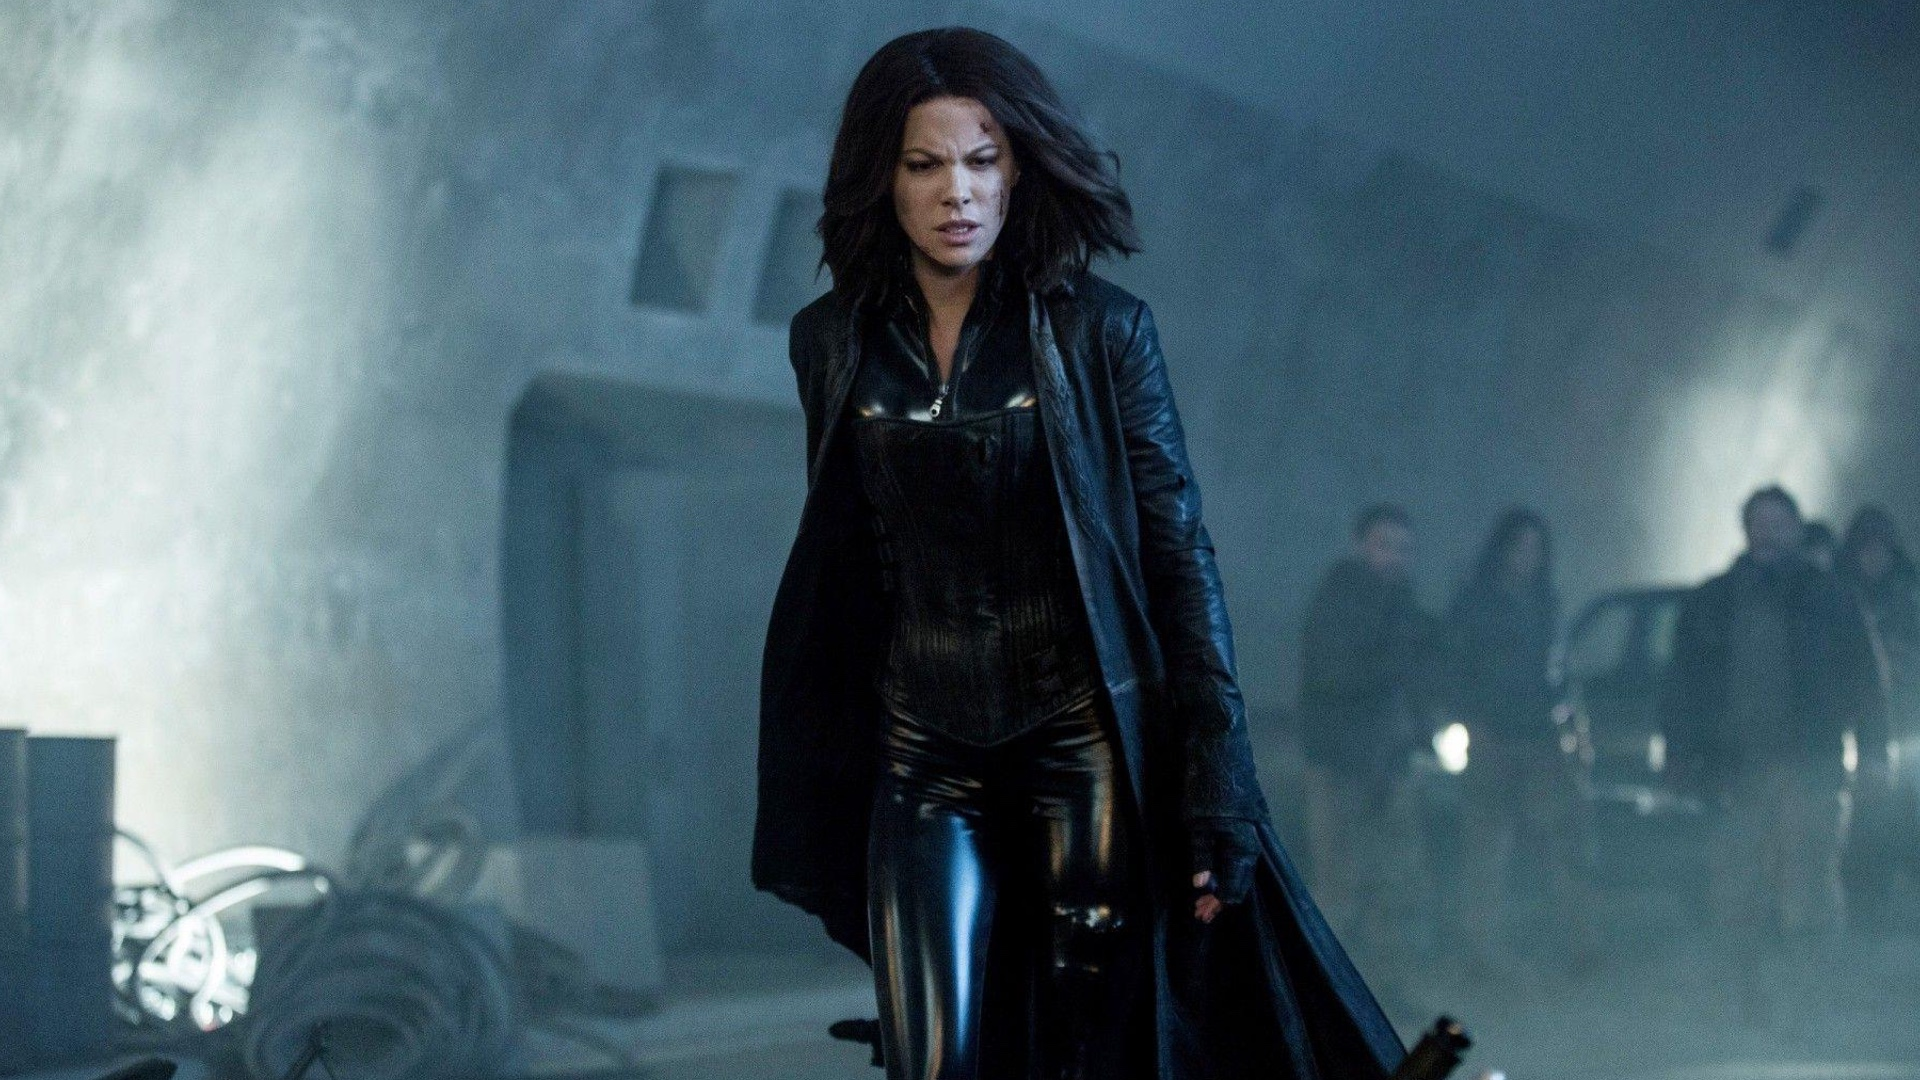Can you describe the mood and atmosphere of this scene? The image exudes a dark and ominous mood, typical of the Underworld series. The industrial backdrop, combined with the shrouding fog, creates a sense of mystery and foreboding. Selene's determined stride and focused expression add intensity, hinting at impending action or confrontation. The overall atmosphere is gothic, moody, and filled with tension. How does Selene's attire contribute to the overall tone of the image? Selene's black leather attire plays a crucial role in establishing the tone of the image. The dark, sleek outfit emphasizes themes of power, resilience, and gothic style. The long coat and high boots are not just practical for a warrior but also visually reinforce her role as a fierce and formidable character. This attire, combined with her determined expression and strong posture, enhances the image's intense and moody atmosphere. 